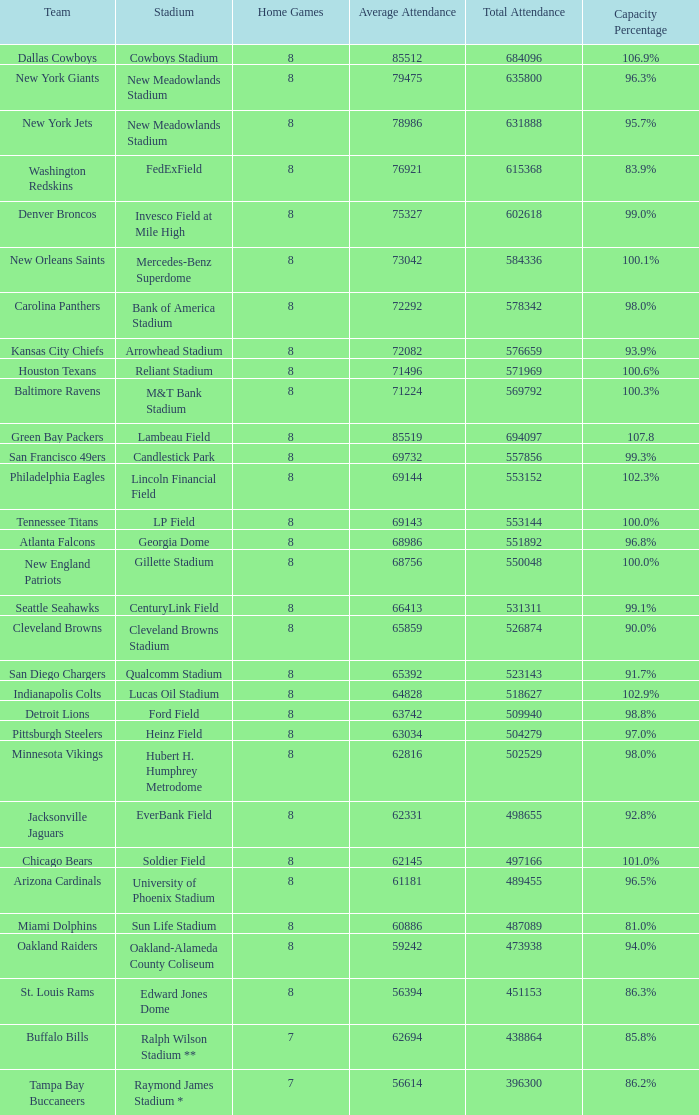What is the capacity percentage when the total attendance is 509940? 98.8%. 